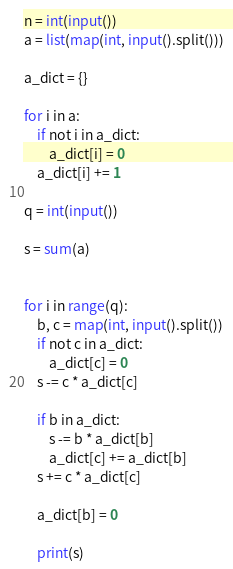Convert code to text. <code><loc_0><loc_0><loc_500><loc_500><_Python_>n = int(input())
a = list(map(int, input().split()))

a_dict = {}

for i in a:
    if not i in a_dict:
        a_dict[i] = 0
    a_dict[i] += 1

q = int(input())

s = sum(a)


for i in range(q):
    b, c = map(int, input().split())
    if not c in a_dict:
        a_dict[c] = 0
    s -= c * a_dict[c]

    if b in a_dict:
        s -= b * a_dict[b]
        a_dict[c] += a_dict[b]
    s += c * a_dict[c]

    a_dict[b] = 0

    print(s)</code> 